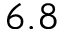<formula> <loc_0><loc_0><loc_500><loc_500>6 . 8</formula> 